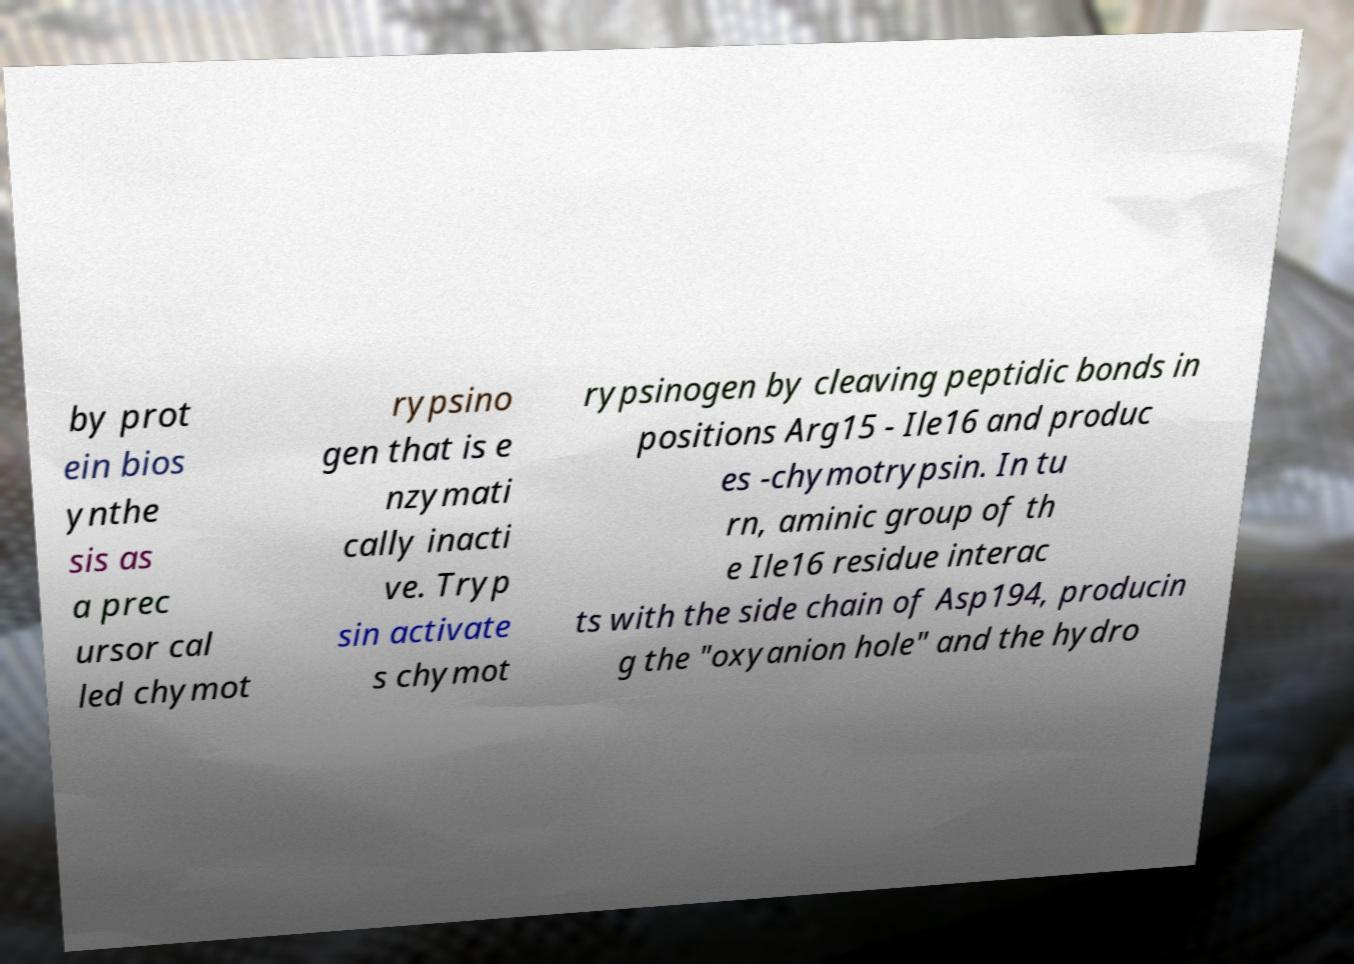Please read and relay the text visible in this image. What does it say? by prot ein bios ynthe sis as a prec ursor cal led chymot rypsino gen that is e nzymati cally inacti ve. Tryp sin activate s chymot rypsinogen by cleaving peptidic bonds in positions Arg15 - Ile16 and produc es -chymotrypsin. In tu rn, aminic group of th e Ile16 residue interac ts with the side chain of Asp194, producin g the "oxyanion hole" and the hydro 